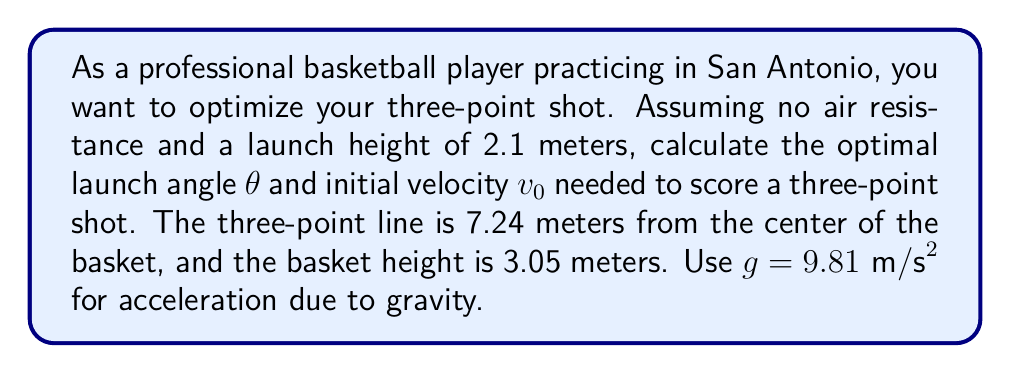Could you help me with this problem? To solve this problem, we'll use projectile motion equations and optimize for the minimum initial velocity required to make the shot.

1. First, let's define our variables:
   x = horizontal distance = 7.24 m
   y = vertical distance = 3.05 m - 2.1 m = 0.95 m
   g = 9.81 m/s²

2. The equations for projectile motion are:
   $$x = v_0 \cos(\theta) t$$
   $$y = v_0 \sin(\theta) t - \frac{1}{2}gt^2$$

3. We can eliminate t by solving the first equation for t and substituting into the second:
   $$t = \frac{x}{v_0 \cos(\theta)}$$
   $$y = v_0 \sin(\theta) \frac{x}{v_0 \cos(\theta)} - \frac{1}{2}g\left(\frac{x}{v_0 \cos(\theta)}\right)^2$$

4. Simplify:
   $$y = x \tan(\theta) - \frac{gx^2}{2v_0^2\cos^2(\theta)}$$

5. Rearrange to solve for v0:
   $$v_0 = \sqrt{\frac{gx^2}{2\cos^2(\theta)(x\tan(\theta) - y)}}$$

6. To find the optimal angle, we differentiate v0 with respect to θ and set it to zero. This leads to:
   $$\tan(\theta) = \frac{3x}{2y}$$

7. Solving for θ:
   $$\theta = \arctan\left(\frac{3x}{2y}\right) = \arctan\left(\frac{3(7.24)}{2(0.95)}\right) = 67.6°$$

8. Substitute this angle back into the equation for v0:
   $$v_0 = \sqrt{\frac{9.81 \cdot 7.24^2}{2\cos^2(67.6°)(7.24\tan(67.6°) - 0.95)}} = 8.15 \text{ m/s}$$
Answer: The optimal launch angle is θ = 67.6°, and the required initial velocity is v0 = 8.15 m/s. 